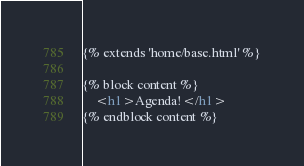Convert code to text. <code><loc_0><loc_0><loc_500><loc_500><_HTML_>{% extends 'home/base.html' %}

{% block content %}
    <h1>Agenda!</h1>
{% endblock content %}</code> 